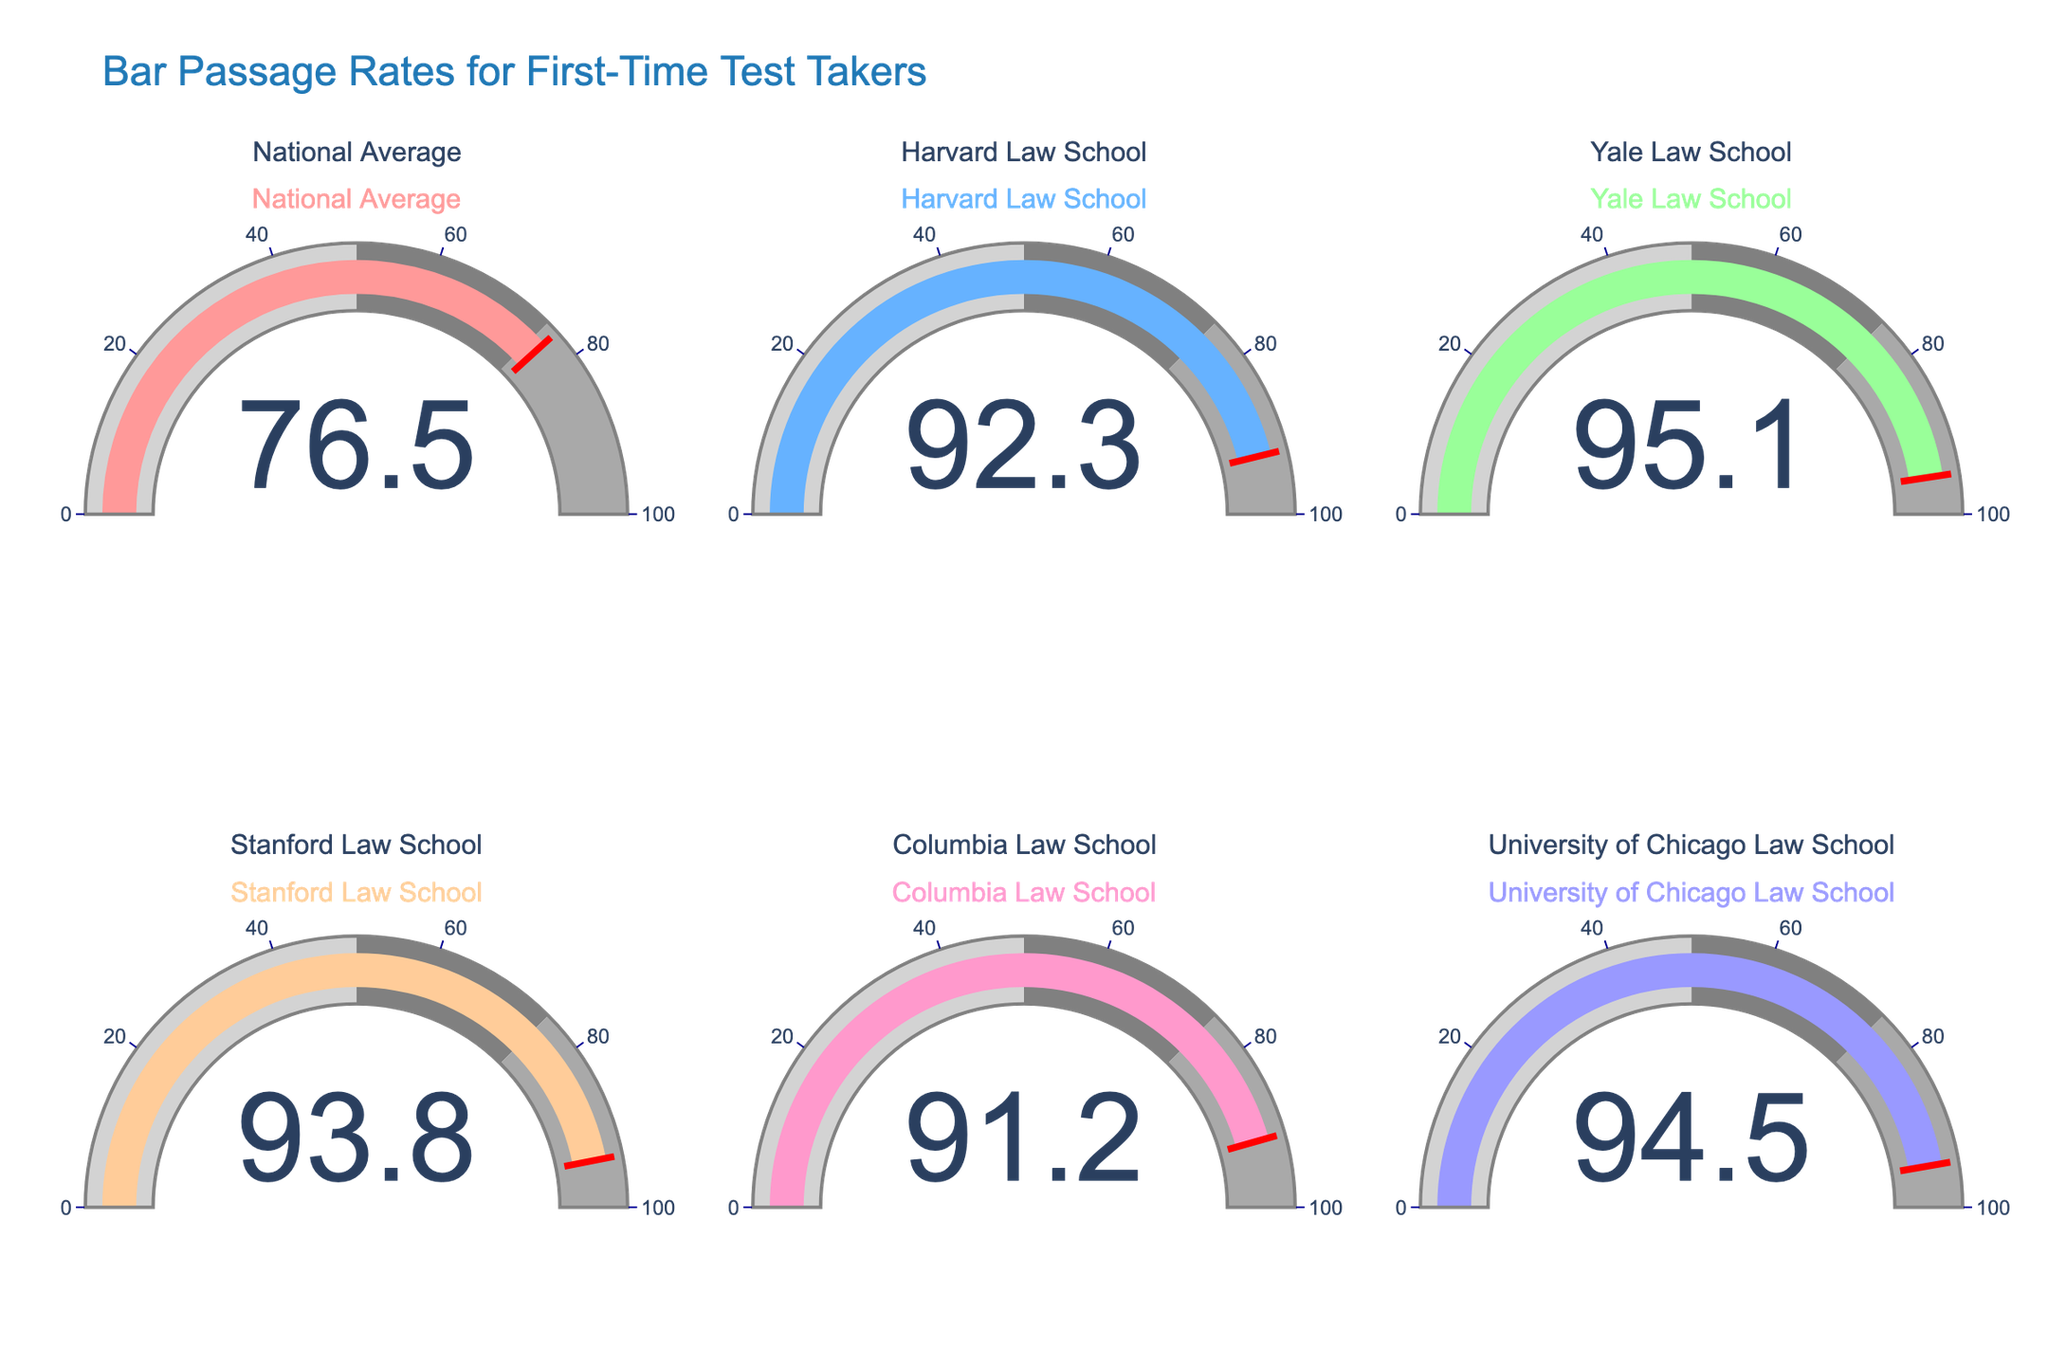What is the bar passage rate of Yale Law School? Look at the gauge chart labeled 'Yale Law School' and read the numerical value displayed at the center of the gauge.
Answer: 95.1 Which law school has the highest bar passage rate? Compare the values displayed in the center of each gauge chart. Identify the highest value among them.
Answer: Yale Law School How does Harvard Law School's bar passage rate compare to the national average? Read the values from the gauge charts labeled 'Harvard Law School' and 'National Average'. Compare the two values.
Answer: 92.3 is higher than 76.5 What is the average bar passage rate of the listed law schools (excluding the national average)? Sum of the values for all the listed law schools (92.3 + 95.1 + 93.8 + 91.2 + 94.5), then divide by the number of schools (5).
Answer: 93.38 Which law school has the lowest bar passage rate? Compare the numerical values displayed at the center of each gauge chart to find the lowest one.
Answer: Columbia Law School Is the bar passage rate of Stanford Law School above or below 90%? Look at the gauge chart labeled 'Stanford Law School' and check if the numerical value exceeds 90%.
Answer: Above What is the range of the bar passage rates among these law schools? Identify the highest value and the lowest value from the gauge charts. Subtract the lowest value from the highest value (95.1 - 91.2).
Answer: 3.9 How much higher is the University of Chicago's bar passage rate compared to Columbia's? Subtract the value of Columbia Law School's rate from the value of University of Chicago Law School’s rate (94.5 - 91.2).
Answer: 3.3 Which schools' bar passage rates are above 90%? Look at each gauge chart and identify those with values greater than 90%.
Answer: Harvard, Yale, Stanford, Columbia, Chicago What is the median bar passage rate among the listed law schools? List the values in ascending order (91.2, 92.3, 93.8, 94.5, 95.1), and identify the middle value.
Answer: 93.8 